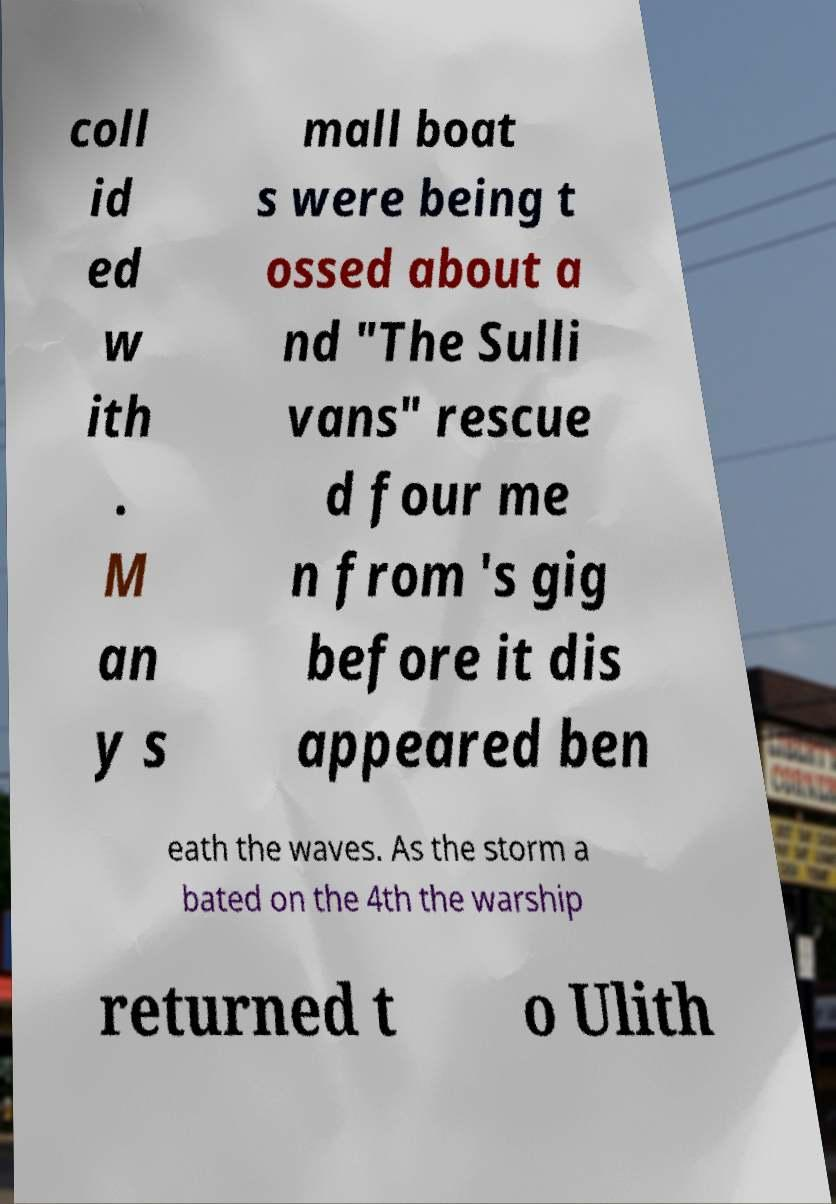Please identify and transcribe the text found in this image. coll id ed w ith . M an y s mall boat s were being t ossed about a nd "The Sulli vans" rescue d four me n from 's gig before it dis appeared ben eath the waves. As the storm a bated on the 4th the warship returned t o Ulith 